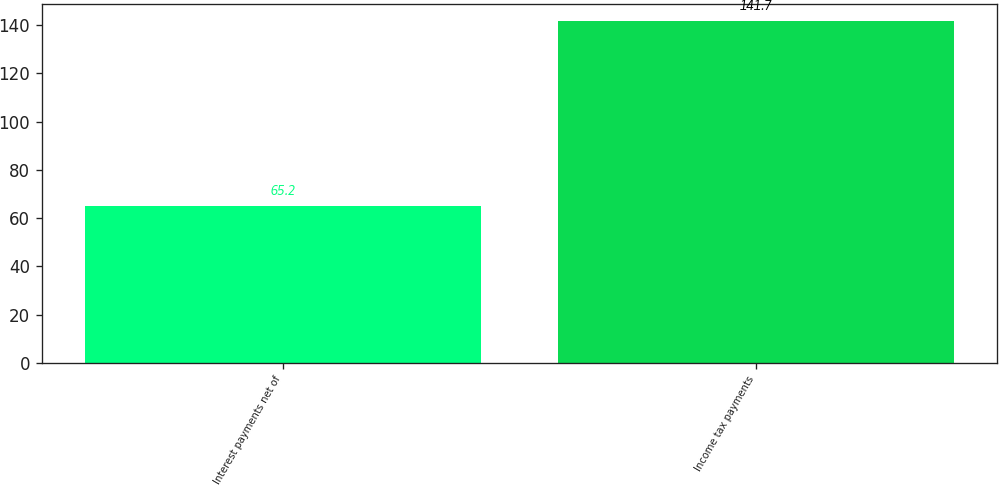Convert chart to OTSL. <chart><loc_0><loc_0><loc_500><loc_500><bar_chart><fcel>Interest payments net of<fcel>Income tax payments<nl><fcel>65.2<fcel>141.7<nl></chart> 